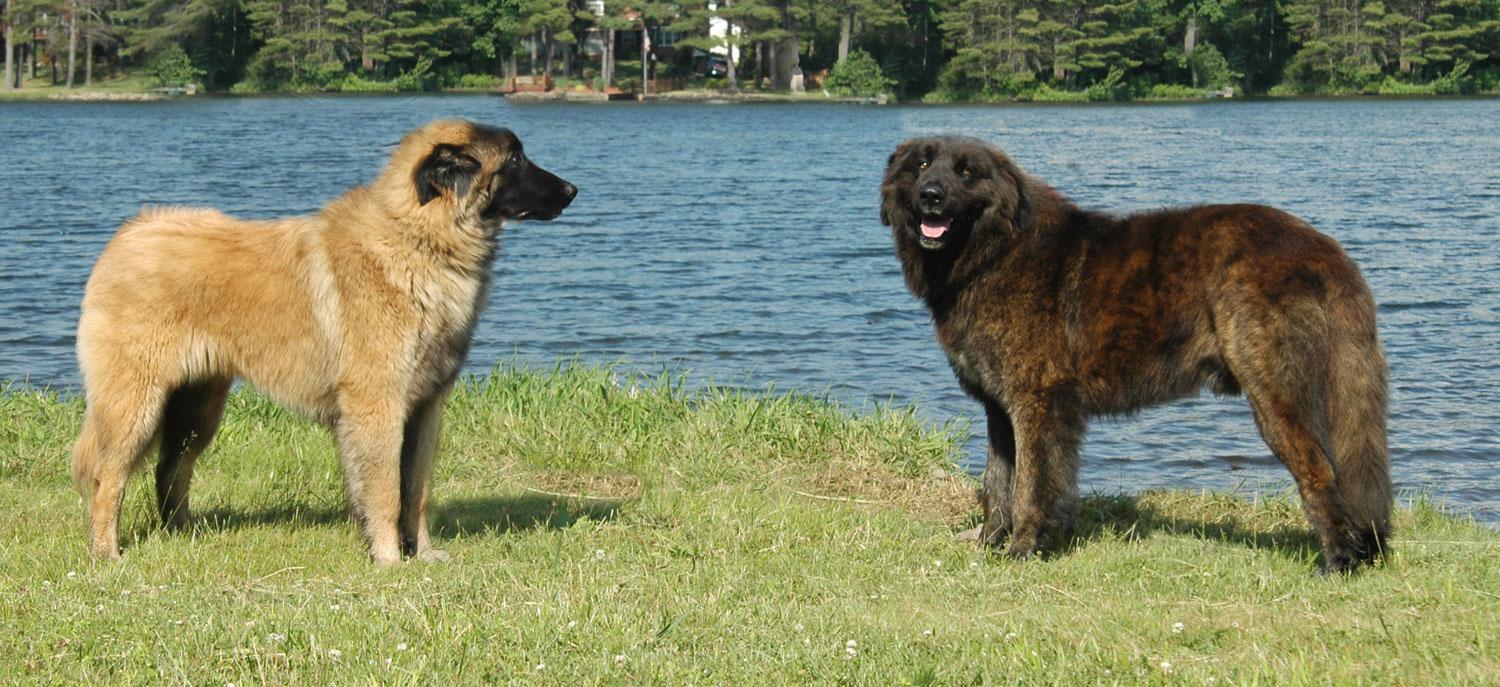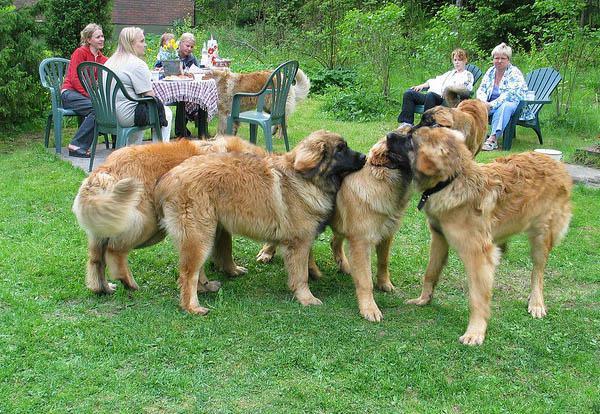The first image is the image on the left, the second image is the image on the right. For the images displayed, is the sentence "A female with bent knees is on the left of a big dog, which is the only dog in the image." factually correct? Answer yes or no. No. The first image is the image on the left, the second image is the image on the right. Given the left and right images, does the statement "The left image contains exactly two dogs." hold true? Answer yes or no. Yes. 